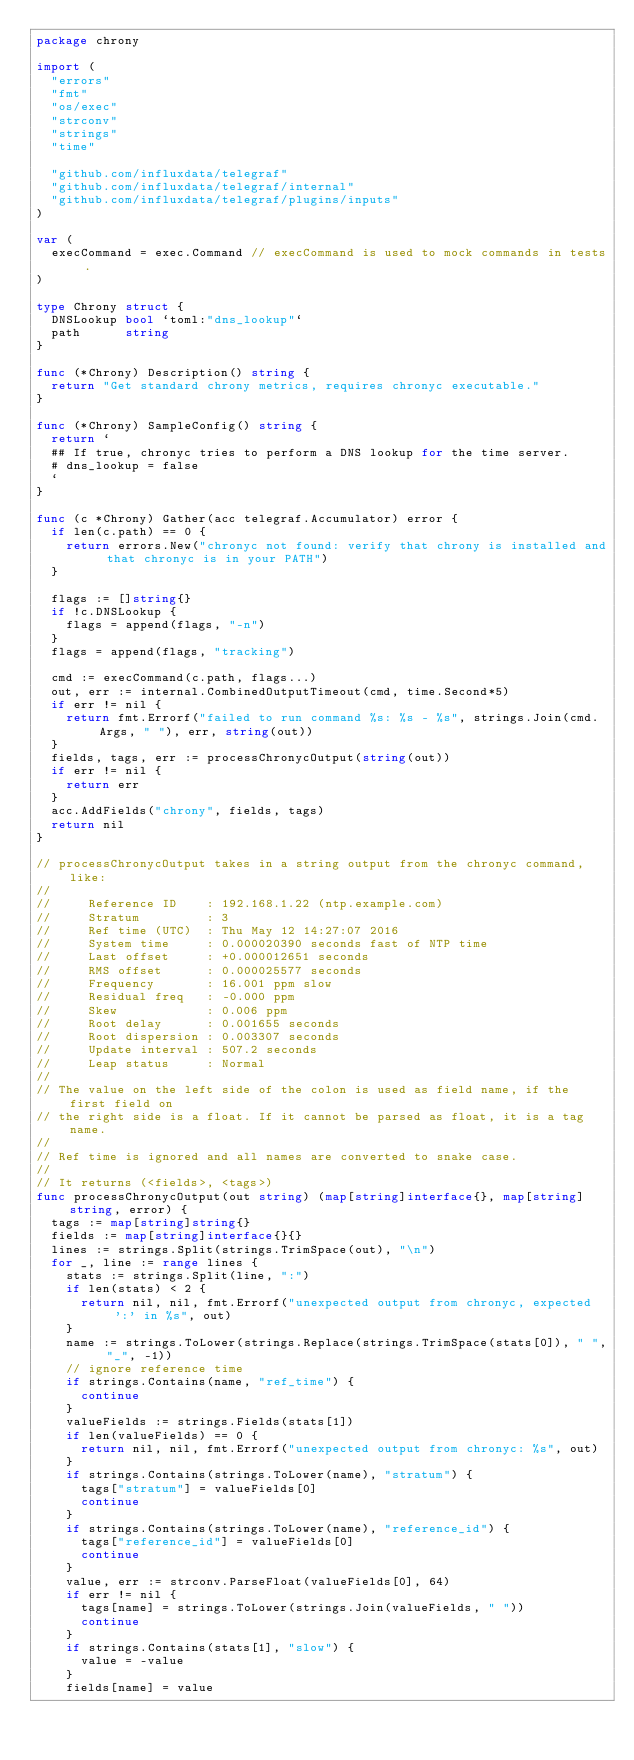Convert code to text. <code><loc_0><loc_0><loc_500><loc_500><_Go_>package chrony

import (
	"errors"
	"fmt"
	"os/exec"
	"strconv"
	"strings"
	"time"

	"github.com/influxdata/telegraf"
	"github.com/influxdata/telegraf/internal"
	"github.com/influxdata/telegraf/plugins/inputs"
)

var (
	execCommand = exec.Command // execCommand is used to mock commands in tests.
)

type Chrony struct {
	DNSLookup bool `toml:"dns_lookup"`
	path      string
}

func (*Chrony) Description() string {
	return "Get standard chrony metrics, requires chronyc executable."
}

func (*Chrony) SampleConfig() string {
	return `
  ## If true, chronyc tries to perform a DNS lookup for the time server.
  # dns_lookup = false
  `
}

func (c *Chrony) Gather(acc telegraf.Accumulator) error {
	if len(c.path) == 0 {
		return errors.New("chronyc not found: verify that chrony is installed and that chronyc is in your PATH")
	}

	flags := []string{}
	if !c.DNSLookup {
		flags = append(flags, "-n")
	}
	flags = append(flags, "tracking")

	cmd := execCommand(c.path, flags...)
	out, err := internal.CombinedOutputTimeout(cmd, time.Second*5)
	if err != nil {
		return fmt.Errorf("failed to run command %s: %s - %s", strings.Join(cmd.Args, " "), err, string(out))
	}
	fields, tags, err := processChronycOutput(string(out))
	if err != nil {
		return err
	}
	acc.AddFields("chrony", fields, tags)
	return nil
}

// processChronycOutput takes in a string output from the chronyc command, like:
//
//     Reference ID    : 192.168.1.22 (ntp.example.com)
//     Stratum         : 3
//     Ref time (UTC)  : Thu May 12 14:27:07 2016
//     System time     : 0.000020390 seconds fast of NTP time
//     Last offset     : +0.000012651 seconds
//     RMS offset      : 0.000025577 seconds
//     Frequency       : 16.001 ppm slow
//     Residual freq   : -0.000 ppm
//     Skew            : 0.006 ppm
//     Root delay      : 0.001655 seconds
//     Root dispersion : 0.003307 seconds
//     Update interval : 507.2 seconds
//     Leap status     : Normal
//
// The value on the left side of the colon is used as field name, if the first field on
// the right side is a float. If it cannot be parsed as float, it is a tag name.
//
// Ref time is ignored and all names are converted to snake case.
//
// It returns (<fields>, <tags>)
func processChronycOutput(out string) (map[string]interface{}, map[string]string, error) {
	tags := map[string]string{}
	fields := map[string]interface{}{}
	lines := strings.Split(strings.TrimSpace(out), "\n")
	for _, line := range lines {
		stats := strings.Split(line, ":")
		if len(stats) < 2 {
			return nil, nil, fmt.Errorf("unexpected output from chronyc, expected ':' in %s", out)
		}
		name := strings.ToLower(strings.Replace(strings.TrimSpace(stats[0]), " ", "_", -1))
		// ignore reference time
		if strings.Contains(name, "ref_time") {
			continue
		}
		valueFields := strings.Fields(stats[1])
		if len(valueFields) == 0 {
			return nil, nil, fmt.Errorf("unexpected output from chronyc: %s", out)
		}
		if strings.Contains(strings.ToLower(name), "stratum") {
			tags["stratum"] = valueFields[0]
			continue
		}
		if strings.Contains(strings.ToLower(name), "reference_id") {
			tags["reference_id"] = valueFields[0]
			continue
		}
		value, err := strconv.ParseFloat(valueFields[0], 64)
		if err != nil {
			tags[name] = strings.ToLower(strings.Join(valueFields, " "))
			continue
		}
		if strings.Contains(stats[1], "slow") {
			value = -value
		}
		fields[name] = value</code> 